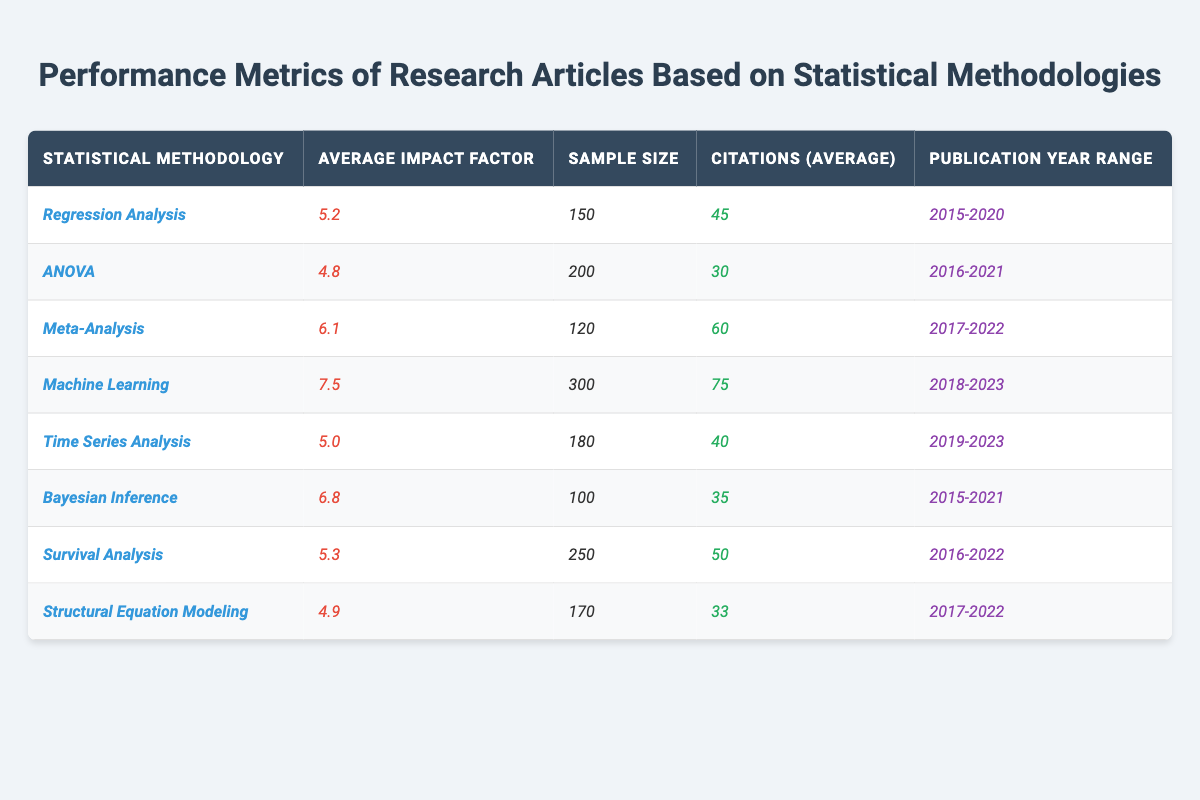What is the average impact factor of articles that used *Machine Learning*? The average impact factor for the *Machine Learning* methodology is listed directly in the table as *7.5*.
Answer: 7.5 How many citations on average did articles using *Bayesian Inference* receive? The table shows that *Bayesian Inference* articles received an average of *35* citations.
Answer: 35 What is the sample size for articles that employed *ANOVA*? The sample size for articles using *ANOVA* is stated in the table as *200*.
Answer: 200 Which statistical methodology has the highest average impact factor? By comparing the average impact factors, *Machine Learning* has the highest at *7.5*.
Answer: *Machine Learning* How many more citations did articles using *Meta-Analysis* receive compared to those using *ANOVA*? Average citations for *Meta-Analysis* are *60*, and for *ANOVA* they are *30*. The difference is *60 - 30 = 30*.
Answer: 30 Is the publication year range for *Survival Analysis* longer than that for *Bayesian Inference*? *Survival Analysis* was published from *2016-2022* and *Bayesian Inference* from *2015-2021*. This means *Survival Analysis* has a range of *6 years* while *Bayesian Inference* has *7 years*; thus, *Survival Analysis* has a shorter range.
Answer: No What is the total sample size of articles that used *Regression Analysis* and *Time Series Analysis* combined? The sample sizes for *Regression Analysis* and *Time Series Analysis* are *150* and *180*, respectively. Adding these gives *150 + 180 = 330*.
Answer: 330 Which method shows the least average citations, and what is that number? The method with the least citations is *Structural Equation Modeling* at *33* citations.
Answer: 33 If we rank the methodologies based on the average impact factor, what is the rank for *ANOVA*? The average impact factor for *ANOVA* is *4.8*, and ranking all methodologies shows it is in the fourth position from the bottom.
Answer: 4th How does the average impact factor of *Machine Learning* compare to the average impact factor of *Time Series Analysis*? *Machine Learning* has an average impact factor of *7.5*, while *Time Series Analysis* has *5.0*. Thus, *Machine Learning* is *2.5* higher.
Answer: 2.5 higher Is it true that all methodologies listed in the table had a sample size of at least 100? Checking the sample sizes, the smallest is *100* for *Bayesian Inference*. Thus, all methodologies meet the criteria.
Answer: Yes 